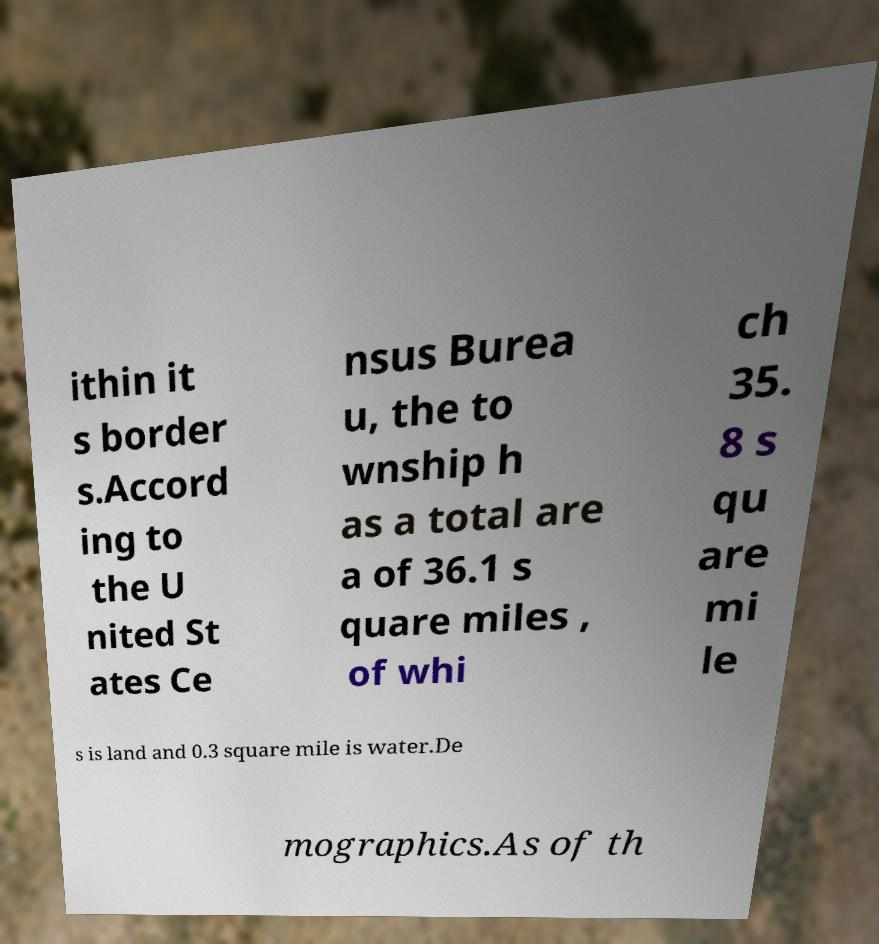Can you accurately transcribe the text from the provided image for me? ithin it s border s.Accord ing to the U nited St ates Ce nsus Burea u, the to wnship h as a total are a of 36.1 s quare miles , of whi ch 35. 8 s qu are mi le s is land and 0.3 square mile is water.De mographics.As of th 